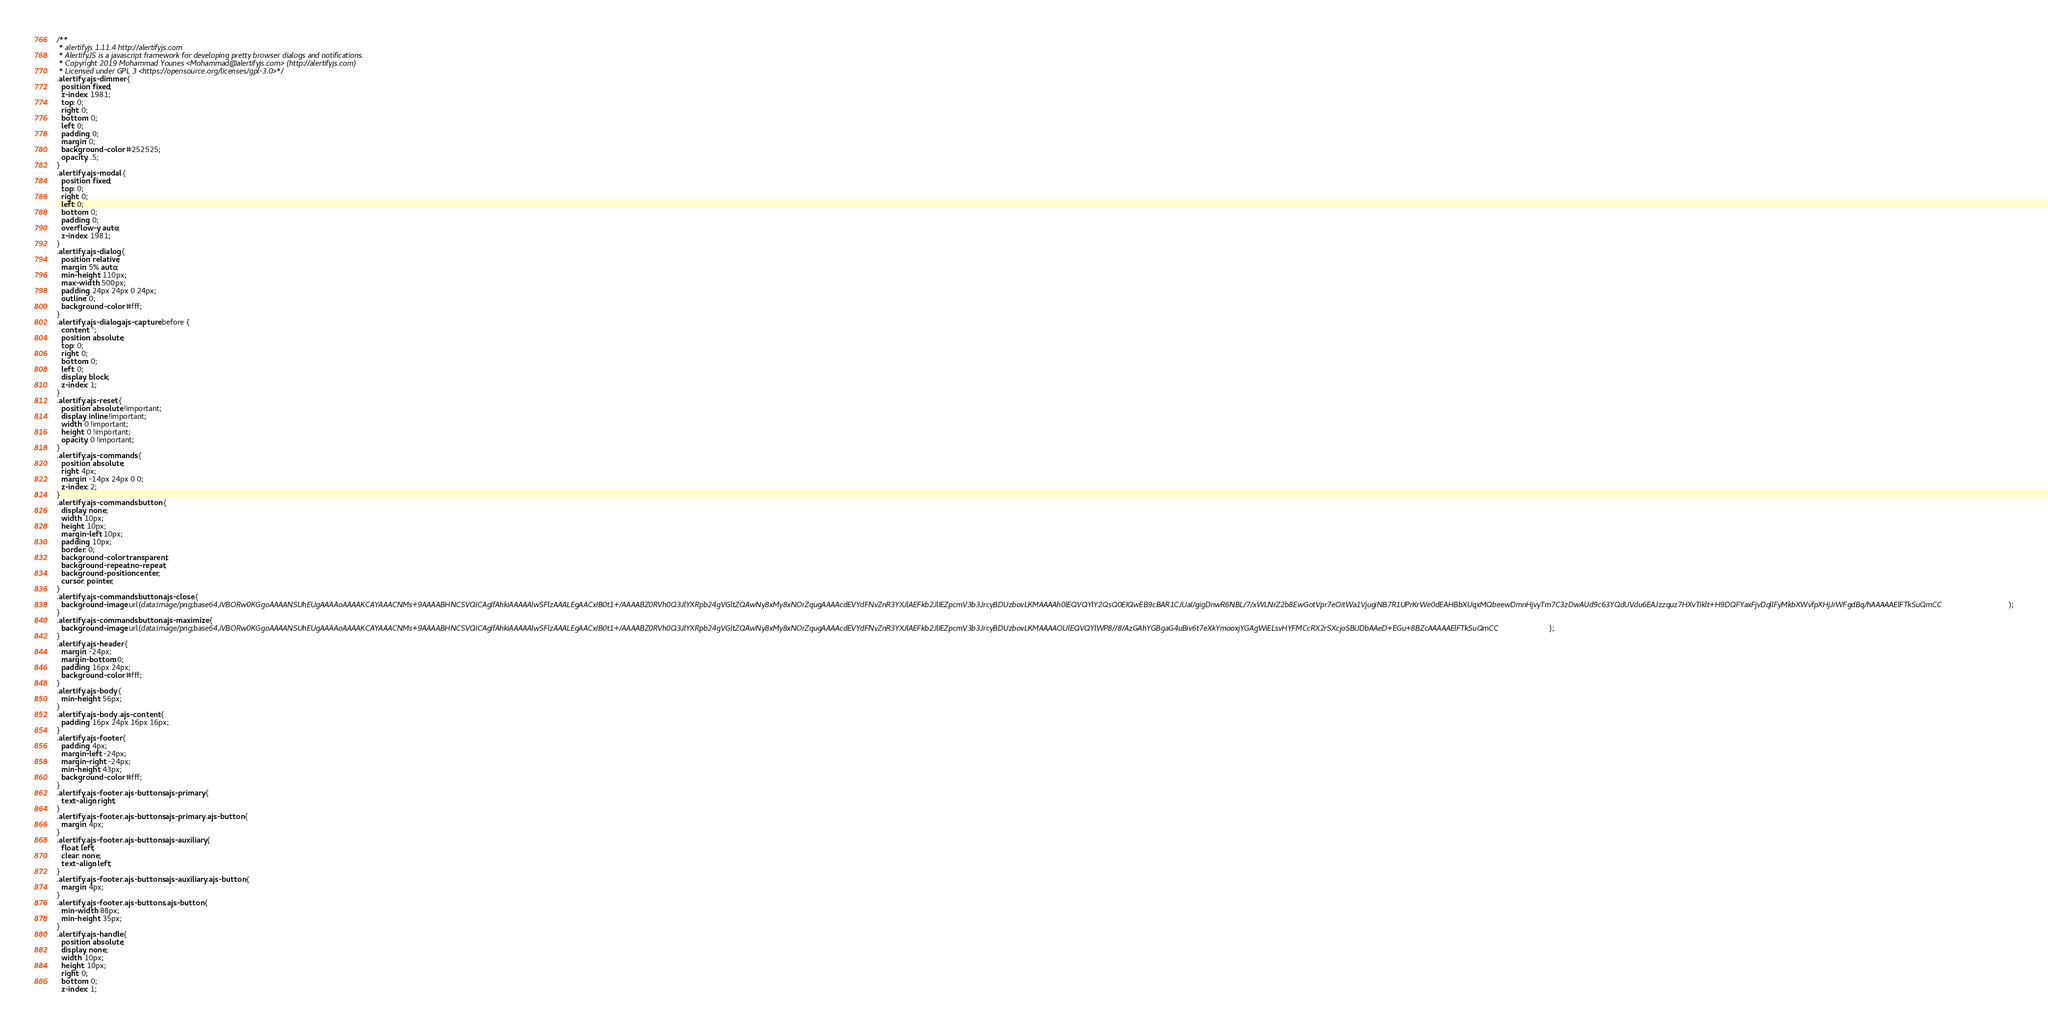<code> <loc_0><loc_0><loc_500><loc_500><_CSS_>/**
 * alertifyjs 1.11.4 http://alertifyjs.com
 * AlertifyJS is a javascript framework for developing pretty browser dialogs and notifications.
 * Copyright 2019 Mohammad Younes <Mohammad@alertifyjs.com> (http://alertifyjs.com) 
 * Licensed under GPL 3 <https://opensource.org/licenses/gpl-3.0>*/
.alertify .ajs-dimmer {
  position: fixed;
  z-index: 1981;
  top: 0;
  right: 0;
  bottom: 0;
  left: 0;
  padding: 0;
  margin: 0;
  background-color: #252525;
  opacity: .5;
}
.alertify .ajs-modal {
  position: fixed;
  top: 0;
  right: 0;
  left: 0;
  bottom: 0;
  padding: 0;
  overflow-y: auto;
  z-index: 1981;
}
.alertify .ajs-dialog {
  position: relative;
  margin: 5% auto;
  min-height: 110px;
  max-width: 500px;
  padding: 24px 24px 0 24px;
  outline: 0;
  background-color: #fff;
}
.alertify .ajs-dialog.ajs-capture:before {
  content: '';
  position: absolute;
  top: 0;
  right: 0;
  bottom: 0;
  left: 0;
  display: block;
  z-index: 1;
}
.alertify .ajs-reset {
  position: absolute !important;
  display: inline !important;
  width: 0 !important;
  height: 0 !important;
  opacity: 0 !important;
}
.alertify .ajs-commands {
  position: absolute;
  right: 4px;
  margin: -14px 24px 0 0;
  z-index: 2;
}
.alertify .ajs-commands button {
  display: none;
  width: 10px;
  height: 10px;
  margin-left: 10px;
  padding: 10px;
  border: 0;
  background-color: transparent;
  background-repeat: no-repeat;
  background-position: center;
  cursor: pointer;
}
.alertify .ajs-commands button.ajs-close {
  background-image: url(data:image/png;base64,iVBORw0KGgoAAAANSUhEUgAAAAoAAAAKCAYAAACNMs+9AAAABHNCSVQICAgIfAhkiAAAAAlwSFlzAAALEgAACxIB0t1+/AAAABZ0RVh0Q3JlYXRpb24gVGltZQAwNy8xMy8xNOrZqugAAAAcdEVYdFNvZnR3YXJlAEFkb2JlIEZpcmV3b3JrcyBDUzbovLKMAAAAh0lEQVQYlY2QsQ0EIQwEB9cBAR1CJUaI/gigDnwR6NBL/7/xWLNrZ2b8EwGotVpr7eOitWa1VjugiNB7R1UPrKrWe0dEAHBbXUqxMQbeewDmnHjvyTm7C3zDwAUd9c63YQdUVdu6EAJzzquz7HXvTiklt+H9DQFYaxFjvDqllFyMkbXWvfpXHjJrWFgdBq/hAAAAAElFTkSuQmCC);
}
.alertify .ajs-commands button.ajs-maximize {
  background-image: url(data:image/png;base64,iVBORw0KGgoAAAANSUhEUgAAAAoAAAAKCAYAAACNMs+9AAAABHNCSVQICAgIfAhkiAAAAAlwSFlzAAALEgAACxIB0t1+/AAAABZ0RVh0Q3JlYXRpb24gVGltZQAwNy8xMy8xNOrZqugAAAAcdEVYdFNvZnR3YXJlAEFkb2JlIEZpcmV3b3JrcyBDUzbovLKMAAAAOUlEQVQYlWP8//8/AzGAhYGBgaG4uBiv6t7eXkYmooxjYGAgWiELsvHYFMCcRX2rSXcjoSBiJDbAAeD+EGu+8BZcAAAAAElFTkSuQmCC);
}
.alertify .ajs-header {
  margin: -24px;
  margin-bottom: 0;
  padding: 16px 24px;
  background-color: #fff;
}
.alertify .ajs-body {
  min-height: 56px;
}
.alertify .ajs-body .ajs-content {
  padding: 16px 24px 16px 16px;
}
.alertify .ajs-footer {
  padding: 4px;
  margin-left: -24px;
  margin-right: -24px;
  min-height: 43px;
  background-color: #fff;
}
.alertify .ajs-footer .ajs-buttons.ajs-primary {
  text-align: right;
}
.alertify .ajs-footer .ajs-buttons.ajs-primary .ajs-button {
  margin: 4px;
}
.alertify .ajs-footer .ajs-buttons.ajs-auxiliary {
  float: left;
  clear: none;
  text-align: left;
}
.alertify .ajs-footer .ajs-buttons.ajs-auxiliary .ajs-button {
  margin: 4px;
}
.alertify .ajs-footer .ajs-buttons .ajs-button {
  min-width: 88px;
  min-height: 35px;
}
.alertify .ajs-handle {
  position: absolute;
  display: none;
  width: 10px;
  height: 10px;
  right: 0;
  bottom: 0;
  z-index: 1;</code> 